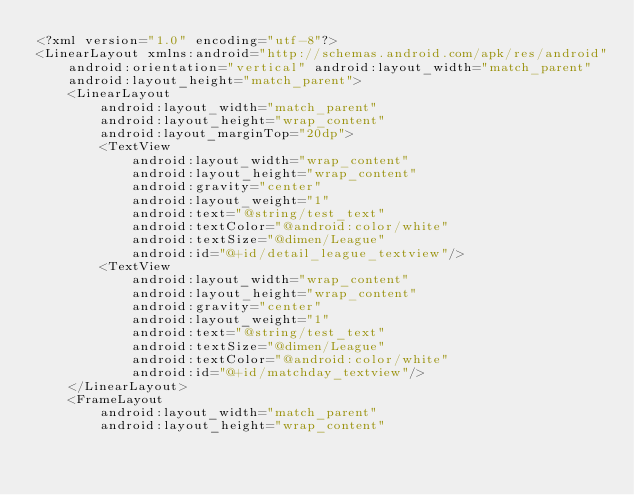<code> <loc_0><loc_0><loc_500><loc_500><_XML_><?xml version="1.0" encoding="utf-8"?>
<LinearLayout xmlns:android="http://schemas.android.com/apk/res/android"
    android:orientation="vertical" android:layout_width="match_parent"
    android:layout_height="match_parent">
    <LinearLayout
        android:layout_width="match_parent"
        android:layout_height="wrap_content"
        android:layout_marginTop="20dp">
        <TextView
            android:layout_width="wrap_content"
            android:layout_height="wrap_content"
            android:gravity="center"
            android:layout_weight="1"
            android:text="@string/test_text"
            android:textColor="@android:color/white"
            android:textSize="@dimen/League"
            android:id="@+id/detail_league_textview"/>
        <TextView
            android:layout_width="wrap_content"
            android:layout_height="wrap_content"
            android:gravity="center"
            android:layout_weight="1"
            android:text="@string/test_text"
            android:textSize="@dimen/League"
            android:textColor="@android:color/white"
            android:id="@+id/matchday_textview"/>
    </LinearLayout>
    <FrameLayout
        android:layout_width="match_parent"
        android:layout_height="wrap_content"</code> 